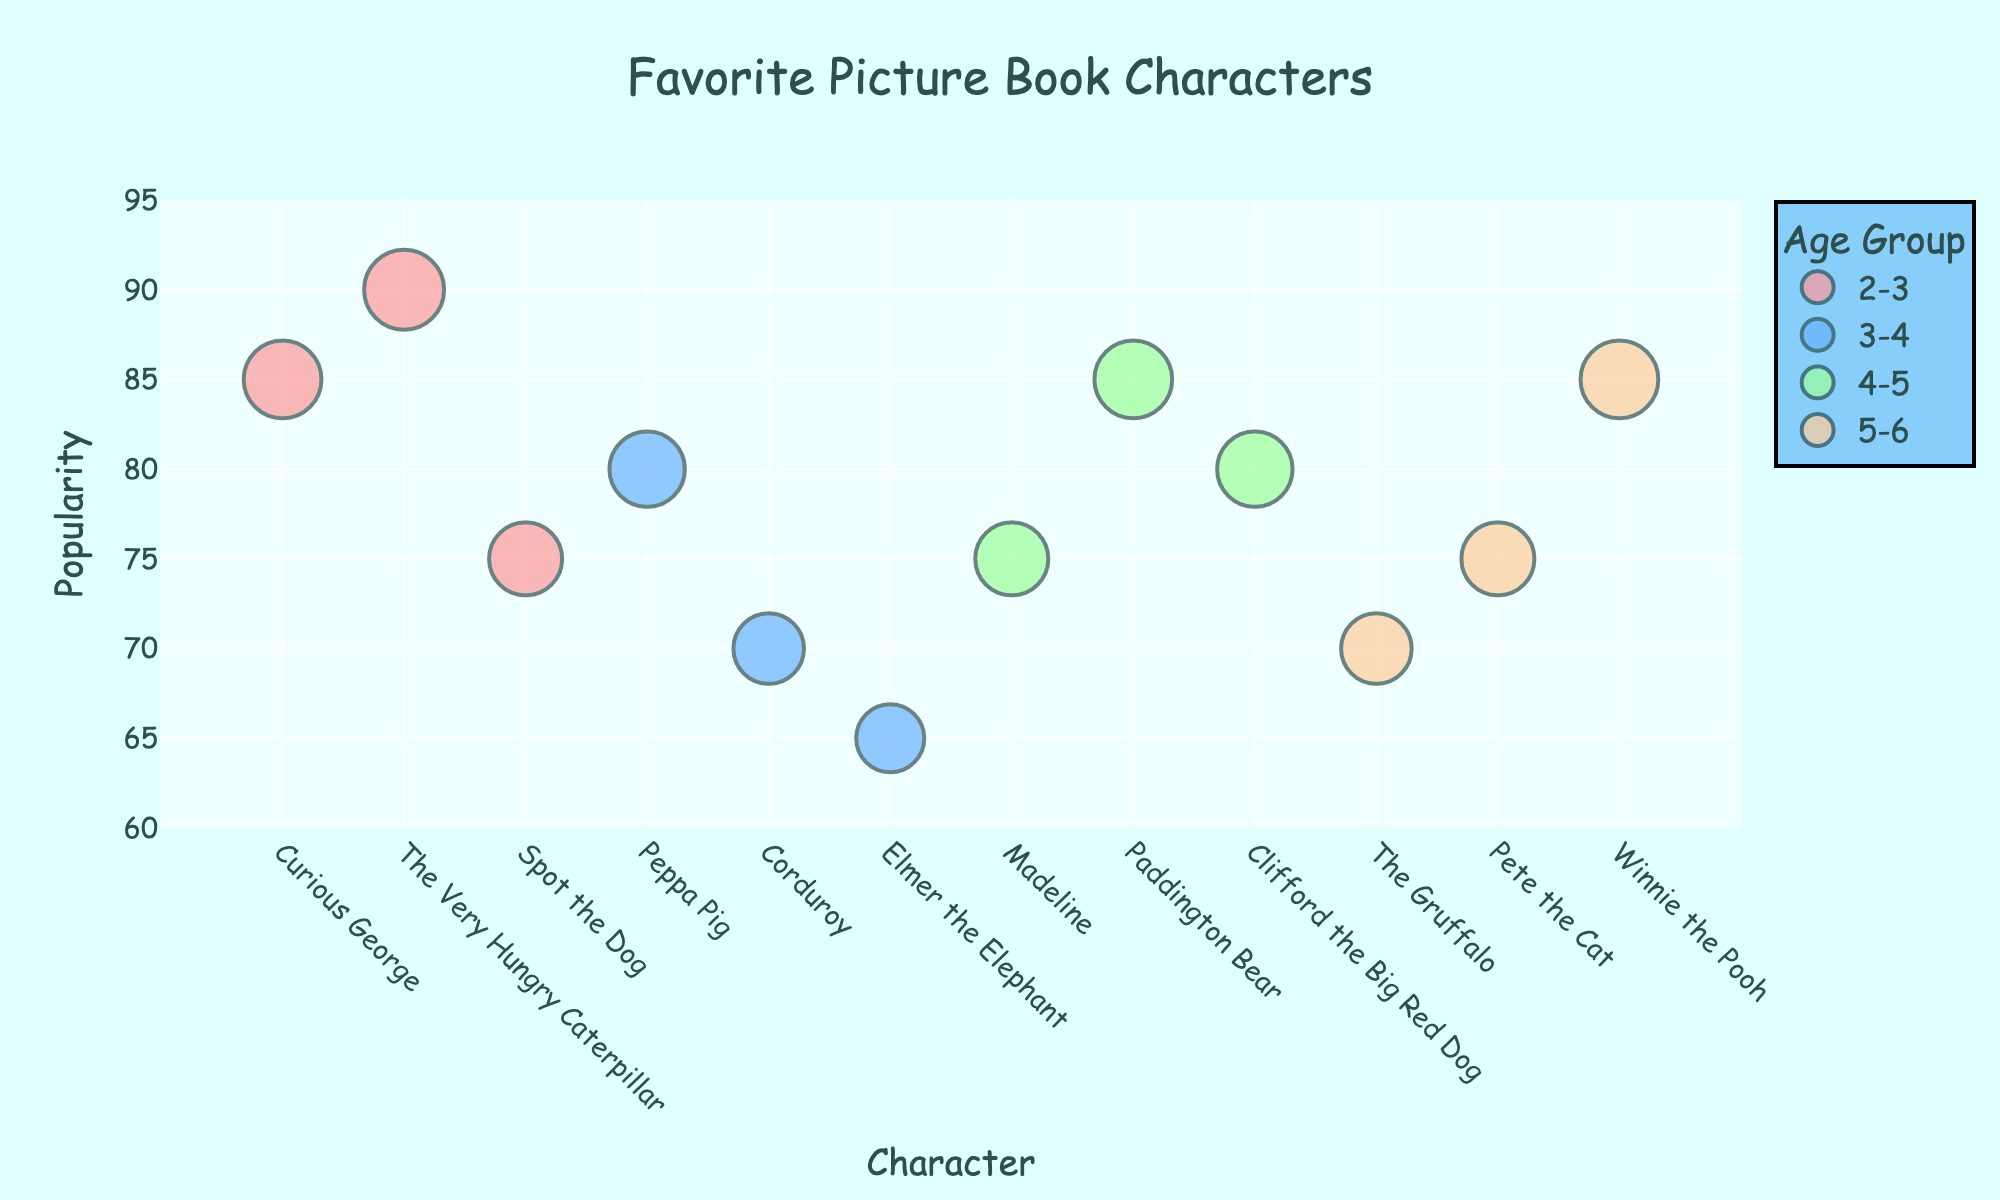What is the title of the plot? The title is typically located at the top of a figure and is written in a larger font size
Answer: Favorite Picture Book Characters What color represents the data points for the age group 2-3? The different age groups are represented by different colored data points. The color for the age group 2-3 can be identified by examining the legend.
Answer: Light Red (Pink) Which character has the highest popularity in the age group 5-6? Look at the characters under the age group 5-6 and identify which has the highest y-value (Popularity).
Answer: Winnie the Pooh How many characters are there in the age group 4-5? Count the number of data points that fall under the age group 4-5, as indicated in the legend.
Answer: 3 What is the difference in popularity between “Corduroy” and “Elmer the Elephant”? Find the y-values for both Corduroy and Elmer the Elephant. Subtract Elmer’s popularity from Corduroy’s popularity.
Answer: 5 (70 - 65) Which age group has the most characters with a popularity greater than 80? Check each age group separately and count how many characters have a popularity above 80 in each group. Compare the counts.
Answer: 2-3 What book series does the character "Curious George" belong to? Hover over (or check the text labels) for the character “Curious George”. The hover info often provides additional details, like the book series.
Answer: Curious George Which age group has the character with the smallest bubble? The smallest bubble corresponds to the smallest size, and size is related to the popularity. Look for the smallest sized bubble and check its age group.
Answer: 3-4 (Elmer the Elephant) What is the average popularity of the characters in the age group 5-6? Find the popularity values for the characters in this age group: (70, 75, 85). Sum them and divide by the number of characters. (70 + 75 + 85) / 3.
Answer: 76.67 Which character is located furthest to the right on the x-axis? Characters are listed along the x-axis. The character that is furthest right would have the highest x position among all characters.
Answer: Winnie the Pooh 